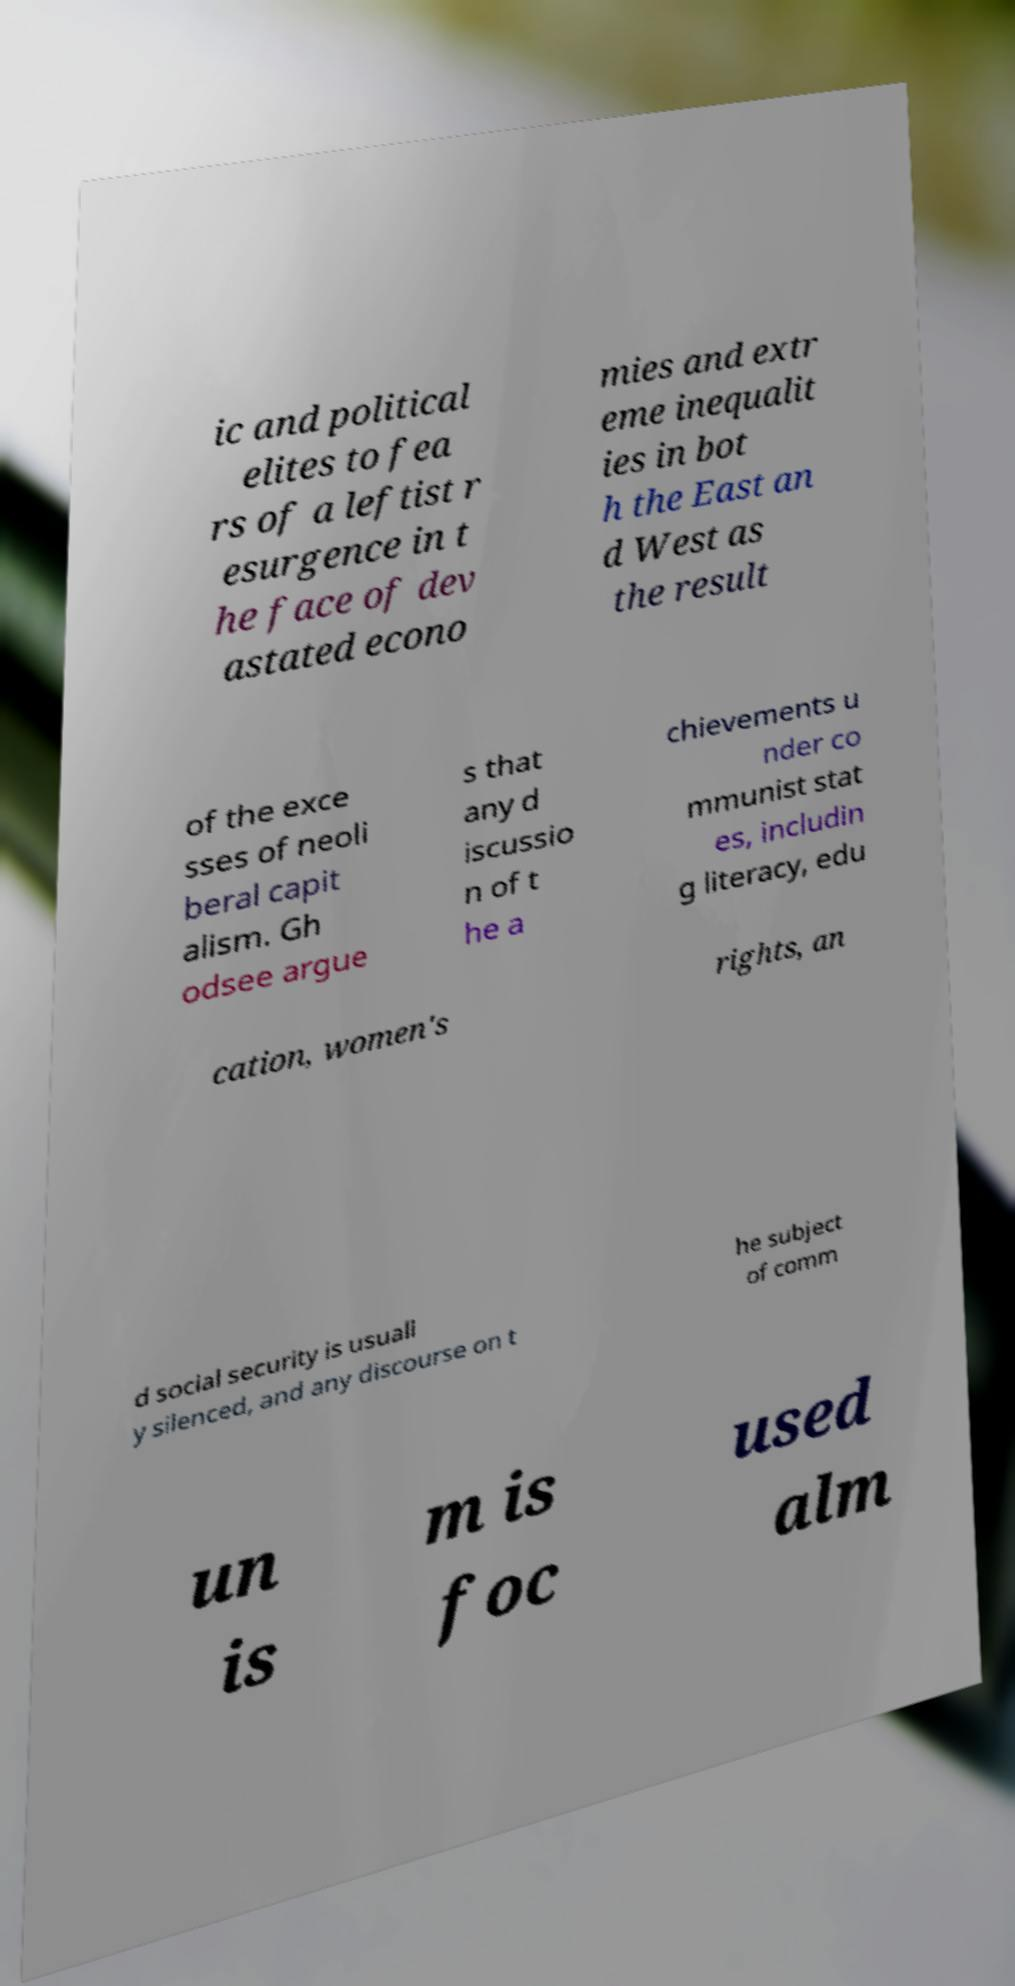Could you assist in decoding the text presented in this image and type it out clearly? ic and political elites to fea rs of a leftist r esurgence in t he face of dev astated econo mies and extr eme inequalit ies in bot h the East an d West as the result of the exce sses of neoli beral capit alism. Gh odsee argue s that any d iscussio n of t he a chievements u nder co mmunist stat es, includin g literacy, edu cation, women's rights, an d social security is usuall y silenced, and any discourse on t he subject of comm un is m is foc used alm 